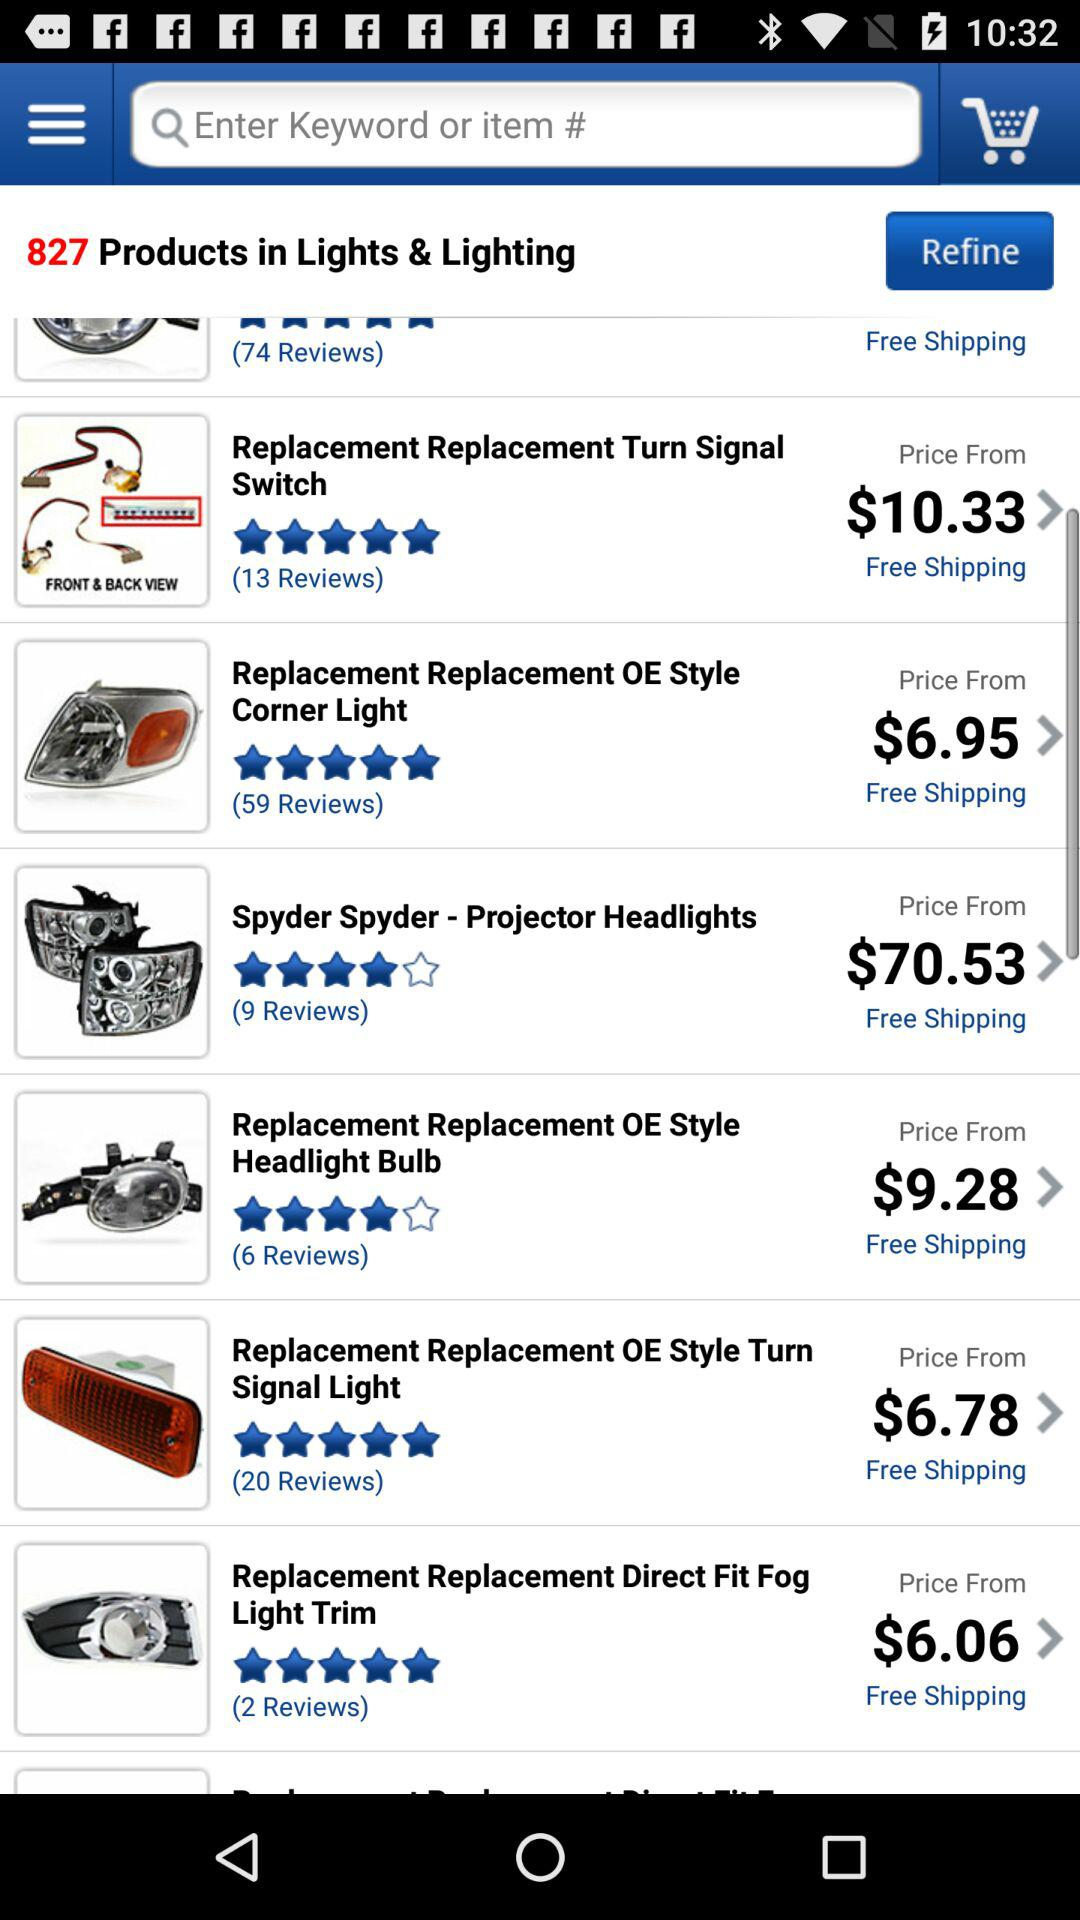What is the star rating of the product "Replacement Replacement Direct Fit Fog Light Trim"? The rating of the product "Replacement Replacement Direct Fit Fog Light Trim" is 5 stars. 